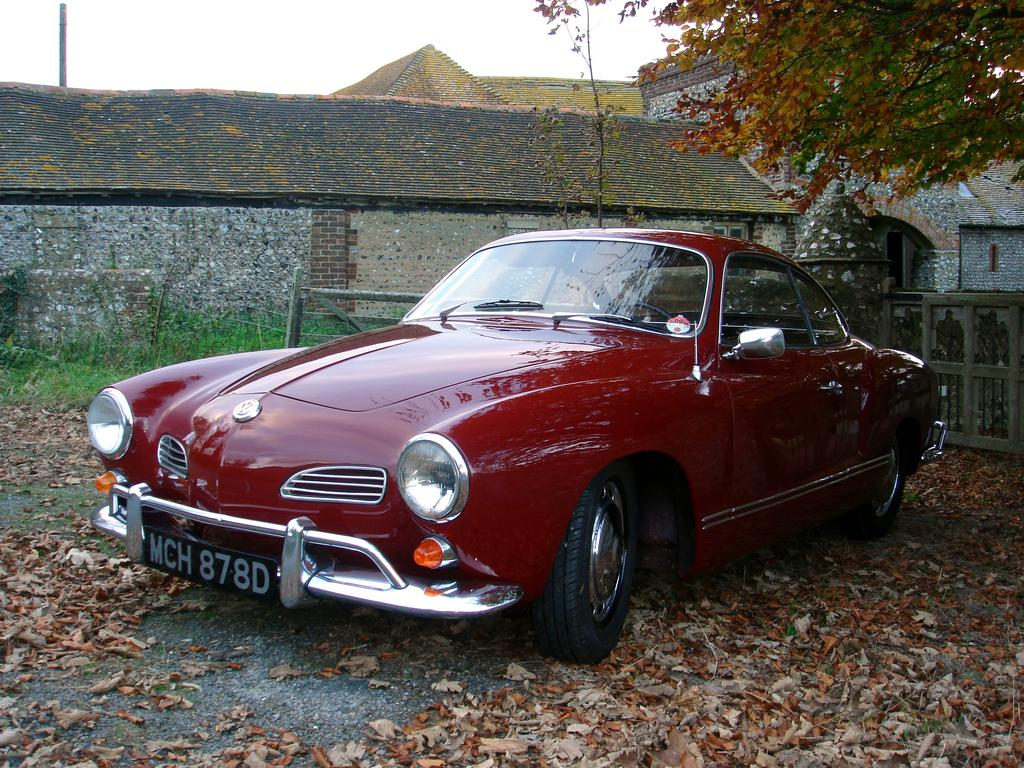What color is the car in the image? The car in the image is red. Where is the car located in the image? The car is on the ground. What can be seen on the ground around the car? Dry leaves are visible on the ground. What is visible in the background of the image? There is a wooden fence, grass, a stone house, trees, and the sky visible in the background of the image. Where are the friends sitting on the throne in the image? There are no friends or thrones present in the image; it features a red car on the ground and various elements in the background. 